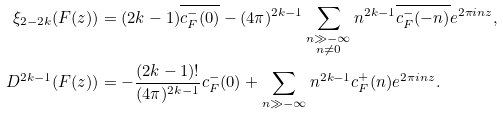Convert formula to latex. <formula><loc_0><loc_0><loc_500><loc_500>\xi _ { 2 - 2 k } ( F ( z ) ) & = ( 2 k - 1 ) \overline { c _ { F } ^ { - } ( 0 ) } - ( 4 \pi ) ^ { 2 k - 1 } \sum _ { \substack { n \gg - \infty \\ n \neq 0 } } n ^ { 2 k - 1 } \overline { c _ { F } ^ { - } ( - n ) } e ^ { 2 \pi i n z } , \\ D ^ { 2 k - 1 } ( F ( z ) ) & = - \frac { ( 2 k - 1 ) ! } { ( 4 \pi ) ^ { 2 k - 1 } } c _ { F } ^ { - } ( 0 ) + \sum _ { n \gg - \infty } n ^ { 2 k - 1 } c _ { F } ^ { + } ( n ) e ^ { 2 \pi i n z } .</formula> 